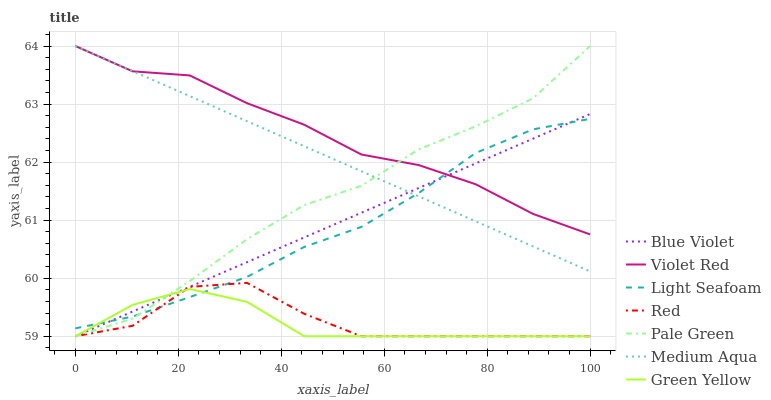Does Pale Green have the minimum area under the curve?
Answer yes or no. No. Does Pale Green have the maximum area under the curve?
Answer yes or no. No. Is Green Yellow the smoothest?
Answer yes or no. No. Is Green Yellow the roughest?
Answer yes or no. No. Does Medium Aqua have the lowest value?
Answer yes or no. No. Does Green Yellow have the highest value?
Answer yes or no. No. Is Green Yellow less than Violet Red?
Answer yes or no. Yes. Is Medium Aqua greater than Red?
Answer yes or no. Yes. Does Green Yellow intersect Violet Red?
Answer yes or no. No. 